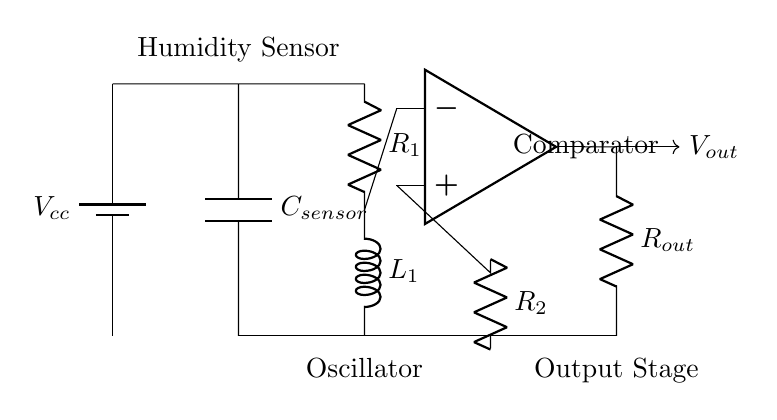What type of sensor is used in this circuit? The circuit diagram indicates a capacitive sensor, labeled as "C_sensor," which is used for detecting humidity levels.
Answer: Capacitive sensor What is the purpose of the resistor labeled R1? Resistor R1 is part of the oscillator circuit and is used to control the timing characteristics of the oscillator. It determines the charge and discharge time of the connected capacitor, affecting the output frequency.
Answer: Oscillator How many passive components are present in this circuit? The circuit contains four passive components: one capacitor (C_sensor), one inductor (L1), and two resistors (R1 and R2). Passive components do not require any external power source to operate.
Answer: Four What is the output of the operational amplifier labeled as "Comparator"? The output of the operational amplifier provides a voltage signal that indicates the moisture level detected by the capacitive sensor, which is labeled as V_out.
Answer: V_out Which part of the circuit is responsible for toggling the output signal? The operational amplifier acts as a comparator, processing the voltage levels from the humidity sensor and changing the output state based on those levels. It toggles the output signal according to the moisture detected.
Answer: Comparator What is the function of the inductor (L1) in this circuit? The inductor L1, used in the oscillator circuit, contributes to the oscillation frequency by allowing current to alternate in the circuit and store energy in its magnetic field, affecting the overall behavior of the oscillation.
Answer: Oscillation frequency 